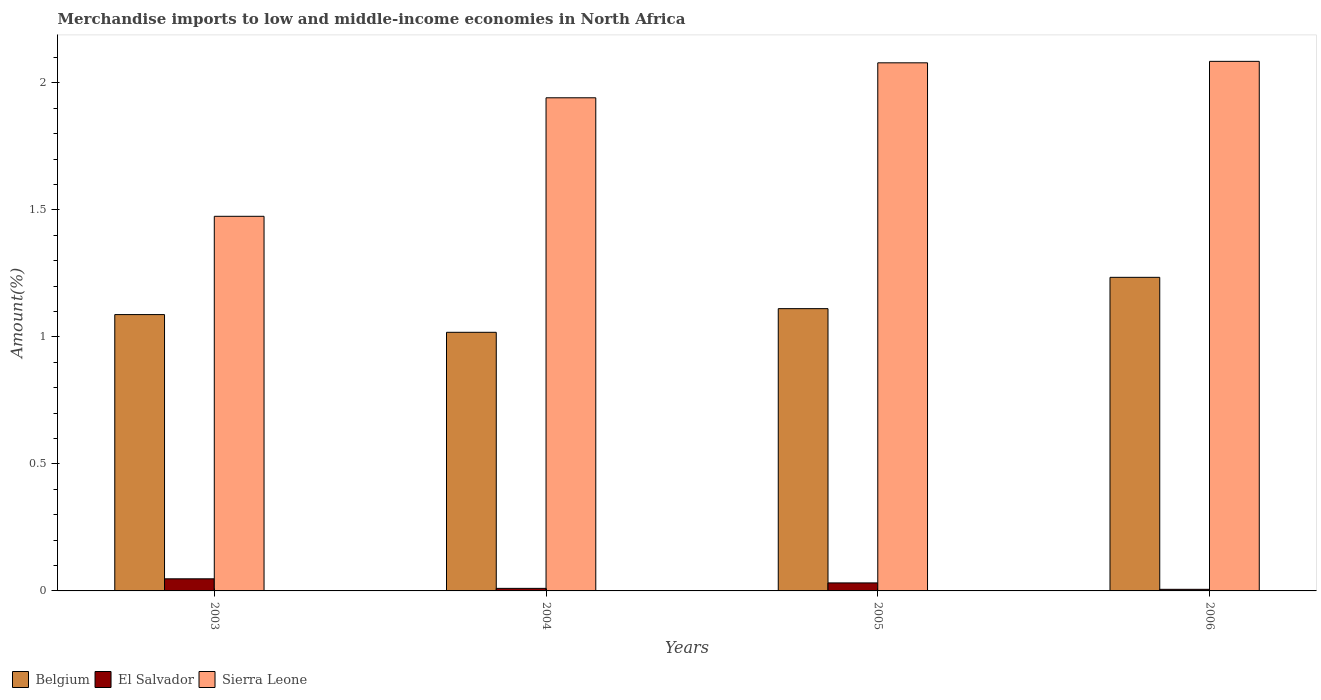How many different coloured bars are there?
Provide a short and direct response. 3. How many bars are there on the 4th tick from the right?
Ensure brevity in your answer.  3. What is the percentage of amount earned from merchandise imports in El Salvador in 2006?
Give a very brief answer. 0.01. Across all years, what is the maximum percentage of amount earned from merchandise imports in Sierra Leone?
Offer a terse response. 2.08. Across all years, what is the minimum percentage of amount earned from merchandise imports in Belgium?
Keep it short and to the point. 1.02. What is the total percentage of amount earned from merchandise imports in Belgium in the graph?
Your response must be concise. 4.45. What is the difference between the percentage of amount earned from merchandise imports in El Salvador in 2004 and that in 2006?
Ensure brevity in your answer.  0. What is the difference between the percentage of amount earned from merchandise imports in Sierra Leone in 2005 and the percentage of amount earned from merchandise imports in El Salvador in 2006?
Your response must be concise. 2.07. What is the average percentage of amount earned from merchandise imports in Belgium per year?
Your response must be concise. 1.11. In the year 2004, what is the difference between the percentage of amount earned from merchandise imports in El Salvador and percentage of amount earned from merchandise imports in Belgium?
Your response must be concise. -1.01. In how many years, is the percentage of amount earned from merchandise imports in Sierra Leone greater than 0.8 %?
Offer a terse response. 4. What is the ratio of the percentage of amount earned from merchandise imports in Sierra Leone in 2005 to that in 2006?
Offer a very short reply. 1. Is the difference between the percentage of amount earned from merchandise imports in El Salvador in 2004 and 2006 greater than the difference between the percentage of amount earned from merchandise imports in Belgium in 2004 and 2006?
Keep it short and to the point. Yes. What is the difference between the highest and the second highest percentage of amount earned from merchandise imports in El Salvador?
Offer a very short reply. 0.02. What is the difference between the highest and the lowest percentage of amount earned from merchandise imports in Sierra Leone?
Your answer should be very brief. 0.61. What does the 1st bar from the right in 2006 represents?
Your answer should be compact. Sierra Leone. Is it the case that in every year, the sum of the percentage of amount earned from merchandise imports in Belgium and percentage of amount earned from merchandise imports in Sierra Leone is greater than the percentage of amount earned from merchandise imports in El Salvador?
Ensure brevity in your answer.  Yes. Are all the bars in the graph horizontal?
Your answer should be very brief. No. How many years are there in the graph?
Offer a very short reply. 4. Are the values on the major ticks of Y-axis written in scientific E-notation?
Keep it short and to the point. No. Does the graph contain any zero values?
Provide a short and direct response. No. Where does the legend appear in the graph?
Provide a succinct answer. Bottom left. How many legend labels are there?
Provide a short and direct response. 3. How are the legend labels stacked?
Make the answer very short. Horizontal. What is the title of the graph?
Provide a short and direct response. Merchandise imports to low and middle-income economies in North Africa. Does "North America" appear as one of the legend labels in the graph?
Your answer should be very brief. No. What is the label or title of the Y-axis?
Offer a terse response. Amount(%). What is the Amount(%) of Belgium in 2003?
Provide a short and direct response. 1.09. What is the Amount(%) of El Salvador in 2003?
Provide a short and direct response. 0.05. What is the Amount(%) of Sierra Leone in 2003?
Offer a very short reply. 1.47. What is the Amount(%) in Belgium in 2004?
Your answer should be compact. 1.02. What is the Amount(%) of El Salvador in 2004?
Make the answer very short. 0.01. What is the Amount(%) of Sierra Leone in 2004?
Keep it short and to the point. 1.94. What is the Amount(%) of Belgium in 2005?
Provide a succinct answer. 1.11. What is the Amount(%) of El Salvador in 2005?
Keep it short and to the point. 0.03. What is the Amount(%) in Sierra Leone in 2005?
Your answer should be very brief. 2.08. What is the Amount(%) in Belgium in 2006?
Offer a terse response. 1.23. What is the Amount(%) of El Salvador in 2006?
Ensure brevity in your answer.  0.01. What is the Amount(%) in Sierra Leone in 2006?
Your answer should be very brief. 2.08. Across all years, what is the maximum Amount(%) of Belgium?
Your response must be concise. 1.23. Across all years, what is the maximum Amount(%) in El Salvador?
Ensure brevity in your answer.  0.05. Across all years, what is the maximum Amount(%) in Sierra Leone?
Offer a terse response. 2.08. Across all years, what is the minimum Amount(%) in Belgium?
Provide a succinct answer. 1.02. Across all years, what is the minimum Amount(%) of El Salvador?
Provide a succinct answer. 0.01. Across all years, what is the minimum Amount(%) of Sierra Leone?
Give a very brief answer. 1.47. What is the total Amount(%) in Belgium in the graph?
Offer a terse response. 4.45. What is the total Amount(%) in El Salvador in the graph?
Give a very brief answer. 0.1. What is the total Amount(%) in Sierra Leone in the graph?
Your answer should be compact. 7.58. What is the difference between the Amount(%) in Belgium in 2003 and that in 2004?
Offer a very short reply. 0.07. What is the difference between the Amount(%) of El Salvador in 2003 and that in 2004?
Offer a terse response. 0.04. What is the difference between the Amount(%) in Sierra Leone in 2003 and that in 2004?
Your response must be concise. -0.47. What is the difference between the Amount(%) in Belgium in 2003 and that in 2005?
Your response must be concise. -0.02. What is the difference between the Amount(%) in El Salvador in 2003 and that in 2005?
Offer a terse response. 0.02. What is the difference between the Amount(%) in Sierra Leone in 2003 and that in 2005?
Your answer should be very brief. -0.6. What is the difference between the Amount(%) in Belgium in 2003 and that in 2006?
Offer a terse response. -0.15. What is the difference between the Amount(%) of El Salvador in 2003 and that in 2006?
Ensure brevity in your answer.  0.04. What is the difference between the Amount(%) of Sierra Leone in 2003 and that in 2006?
Make the answer very short. -0.61. What is the difference between the Amount(%) in Belgium in 2004 and that in 2005?
Provide a succinct answer. -0.09. What is the difference between the Amount(%) of El Salvador in 2004 and that in 2005?
Keep it short and to the point. -0.02. What is the difference between the Amount(%) in Sierra Leone in 2004 and that in 2005?
Offer a very short reply. -0.14. What is the difference between the Amount(%) of Belgium in 2004 and that in 2006?
Your answer should be compact. -0.22. What is the difference between the Amount(%) of El Salvador in 2004 and that in 2006?
Ensure brevity in your answer.  0. What is the difference between the Amount(%) in Sierra Leone in 2004 and that in 2006?
Your answer should be compact. -0.14. What is the difference between the Amount(%) of Belgium in 2005 and that in 2006?
Give a very brief answer. -0.12. What is the difference between the Amount(%) in El Salvador in 2005 and that in 2006?
Your answer should be very brief. 0.03. What is the difference between the Amount(%) in Sierra Leone in 2005 and that in 2006?
Provide a short and direct response. -0.01. What is the difference between the Amount(%) of Belgium in 2003 and the Amount(%) of El Salvador in 2004?
Make the answer very short. 1.08. What is the difference between the Amount(%) of Belgium in 2003 and the Amount(%) of Sierra Leone in 2004?
Offer a very short reply. -0.85. What is the difference between the Amount(%) of El Salvador in 2003 and the Amount(%) of Sierra Leone in 2004?
Provide a short and direct response. -1.89. What is the difference between the Amount(%) of Belgium in 2003 and the Amount(%) of El Salvador in 2005?
Give a very brief answer. 1.06. What is the difference between the Amount(%) in Belgium in 2003 and the Amount(%) in Sierra Leone in 2005?
Ensure brevity in your answer.  -0.99. What is the difference between the Amount(%) of El Salvador in 2003 and the Amount(%) of Sierra Leone in 2005?
Ensure brevity in your answer.  -2.03. What is the difference between the Amount(%) in Belgium in 2003 and the Amount(%) in El Salvador in 2006?
Your answer should be very brief. 1.08. What is the difference between the Amount(%) in Belgium in 2003 and the Amount(%) in Sierra Leone in 2006?
Provide a succinct answer. -1. What is the difference between the Amount(%) in El Salvador in 2003 and the Amount(%) in Sierra Leone in 2006?
Offer a terse response. -2.04. What is the difference between the Amount(%) of Belgium in 2004 and the Amount(%) of El Salvador in 2005?
Offer a very short reply. 0.99. What is the difference between the Amount(%) in Belgium in 2004 and the Amount(%) in Sierra Leone in 2005?
Your answer should be compact. -1.06. What is the difference between the Amount(%) of El Salvador in 2004 and the Amount(%) of Sierra Leone in 2005?
Your response must be concise. -2.07. What is the difference between the Amount(%) of Belgium in 2004 and the Amount(%) of El Salvador in 2006?
Provide a short and direct response. 1.01. What is the difference between the Amount(%) of Belgium in 2004 and the Amount(%) of Sierra Leone in 2006?
Provide a short and direct response. -1.07. What is the difference between the Amount(%) in El Salvador in 2004 and the Amount(%) in Sierra Leone in 2006?
Ensure brevity in your answer.  -2.07. What is the difference between the Amount(%) in Belgium in 2005 and the Amount(%) in El Salvador in 2006?
Keep it short and to the point. 1.1. What is the difference between the Amount(%) in Belgium in 2005 and the Amount(%) in Sierra Leone in 2006?
Offer a very short reply. -0.97. What is the difference between the Amount(%) of El Salvador in 2005 and the Amount(%) of Sierra Leone in 2006?
Give a very brief answer. -2.05. What is the average Amount(%) in Belgium per year?
Provide a short and direct response. 1.11. What is the average Amount(%) in El Salvador per year?
Keep it short and to the point. 0.02. What is the average Amount(%) in Sierra Leone per year?
Offer a terse response. 1.9. In the year 2003, what is the difference between the Amount(%) of Belgium and Amount(%) of El Salvador?
Your answer should be very brief. 1.04. In the year 2003, what is the difference between the Amount(%) of Belgium and Amount(%) of Sierra Leone?
Ensure brevity in your answer.  -0.39. In the year 2003, what is the difference between the Amount(%) of El Salvador and Amount(%) of Sierra Leone?
Ensure brevity in your answer.  -1.43. In the year 2004, what is the difference between the Amount(%) of Belgium and Amount(%) of El Salvador?
Provide a succinct answer. 1.01. In the year 2004, what is the difference between the Amount(%) in Belgium and Amount(%) in Sierra Leone?
Provide a short and direct response. -0.92. In the year 2004, what is the difference between the Amount(%) in El Salvador and Amount(%) in Sierra Leone?
Ensure brevity in your answer.  -1.93. In the year 2005, what is the difference between the Amount(%) in Belgium and Amount(%) in El Salvador?
Offer a terse response. 1.08. In the year 2005, what is the difference between the Amount(%) in Belgium and Amount(%) in Sierra Leone?
Give a very brief answer. -0.97. In the year 2005, what is the difference between the Amount(%) of El Salvador and Amount(%) of Sierra Leone?
Your answer should be very brief. -2.05. In the year 2006, what is the difference between the Amount(%) in Belgium and Amount(%) in El Salvador?
Provide a short and direct response. 1.23. In the year 2006, what is the difference between the Amount(%) in Belgium and Amount(%) in Sierra Leone?
Provide a succinct answer. -0.85. In the year 2006, what is the difference between the Amount(%) of El Salvador and Amount(%) of Sierra Leone?
Your answer should be compact. -2.08. What is the ratio of the Amount(%) in Belgium in 2003 to that in 2004?
Your answer should be very brief. 1.07. What is the ratio of the Amount(%) of El Salvador in 2003 to that in 2004?
Provide a short and direct response. 4.75. What is the ratio of the Amount(%) in Sierra Leone in 2003 to that in 2004?
Your answer should be compact. 0.76. What is the ratio of the Amount(%) in Belgium in 2003 to that in 2005?
Give a very brief answer. 0.98. What is the ratio of the Amount(%) of El Salvador in 2003 to that in 2005?
Offer a terse response. 1.51. What is the ratio of the Amount(%) in Sierra Leone in 2003 to that in 2005?
Your response must be concise. 0.71. What is the ratio of the Amount(%) of Belgium in 2003 to that in 2006?
Your response must be concise. 0.88. What is the ratio of the Amount(%) in El Salvador in 2003 to that in 2006?
Keep it short and to the point. 7.54. What is the ratio of the Amount(%) of Sierra Leone in 2003 to that in 2006?
Give a very brief answer. 0.71. What is the ratio of the Amount(%) in Belgium in 2004 to that in 2005?
Make the answer very short. 0.92. What is the ratio of the Amount(%) of El Salvador in 2004 to that in 2005?
Your answer should be compact. 0.32. What is the ratio of the Amount(%) of Sierra Leone in 2004 to that in 2005?
Your answer should be very brief. 0.93. What is the ratio of the Amount(%) of Belgium in 2004 to that in 2006?
Make the answer very short. 0.82. What is the ratio of the Amount(%) of El Salvador in 2004 to that in 2006?
Provide a short and direct response. 1.59. What is the ratio of the Amount(%) in Sierra Leone in 2004 to that in 2006?
Make the answer very short. 0.93. What is the ratio of the Amount(%) in Belgium in 2005 to that in 2006?
Your answer should be very brief. 0.9. What is the ratio of the Amount(%) of El Salvador in 2005 to that in 2006?
Keep it short and to the point. 4.99. What is the ratio of the Amount(%) of Sierra Leone in 2005 to that in 2006?
Provide a succinct answer. 1. What is the difference between the highest and the second highest Amount(%) of Belgium?
Offer a very short reply. 0.12. What is the difference between the highest and the second highest Amount(%) of El Salvador?
Your response must be concise. 0.02. What is the difference between the highest and the second highest Amount(%) of Sierra Leone?
Give a very brief answer. 0.01. What is the difference between the highest and the lowest Amount(%) of Belgium?
Give a very brief answer. 0.22. What is the difference between the highest and the lowest Amount(%) in El Salvador?
Provide a short and direct response. 0.04. What is the difference between the highest and the lowest Amount(%) of Sierra Leone?
Ensure brevity in your answer.  0.61. 